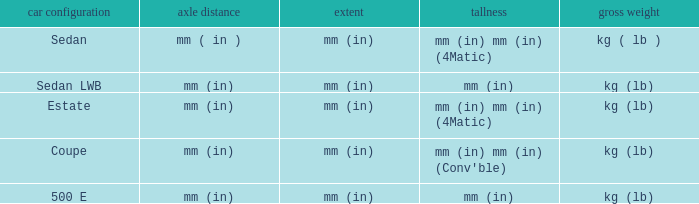What's the curb weight of the model with a wheelbase of mm (in) and height of mm (in) mm (in) (4Matic)? Kg ( lb ), kg (lb). 